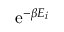<formula> <loc_0><loc_0><loc_500><loc_500>e ^ { - \beta E _ { i } }</formula> 